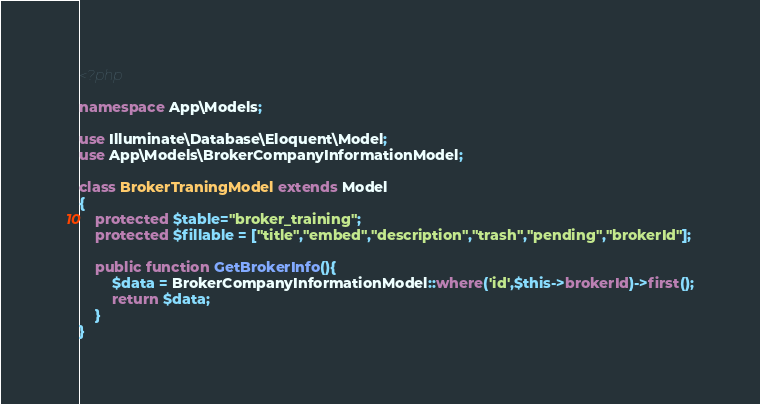<code> <loc_0><loc_0><loc_500><loc_500><_PHP_><?php

namespace App\Models;

use Illuminate\Database\Eloquent\Model;
use App\Models\BrokerCompanyInformationModel;

class BrokerTraningModel extends Model
{
    protected $table="broker_training";
    protected $fillable = ["title","embed","description","trash","pending","brokerId"];
    
    public function GetBrokerInfo(){
        $data = BrokerCompanyInformationModel::where('id',$this->brokerId)->first();
        return $data;
    }
}
</code> 